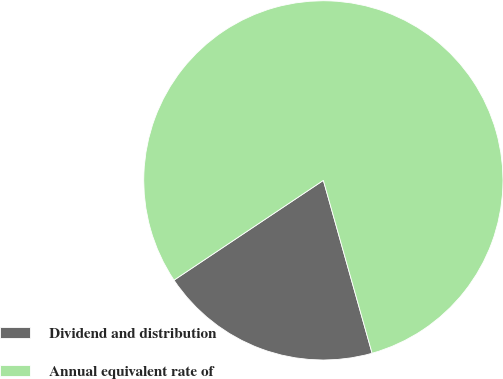Convert chart to OTSL. <chart><loc_0><loc_0><loc_500><loc_500><pie_chart><fcel>Dividend and distribution<fcel>Annual equivalent rate of<nl><fcel>20.0%<fcel>80.0%<nl></chart> 